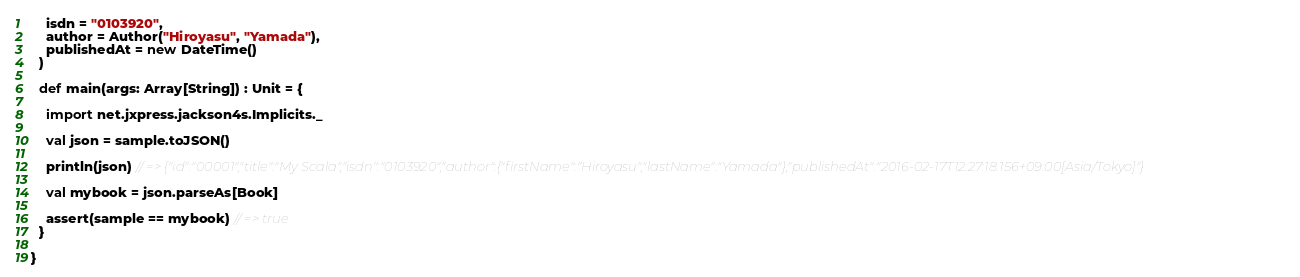Convert code to text. <code><loc_0><loc_0><loc_500><loc_500><_Scala_>    isdn = "0103920",
    author = Author("Hiroyasu", "Yamada"),
    publishedAt = new DateTime()
  )

  def main(args: Array[String]) : Unit = {

    import net.jxpress.jackson4s.Implicits._

    val json = sample.toJSON()

    println(json) // => {"id":"00001","title":"My Scala","isdn":"0103920","author":{"firstName":"Hiroyasu","lastName":"Yamada"},"publishedAt":"2016-02-17T12:27:18.156+09:00[Asia/Tokyo]"}

    val mybook = json.parseAs[Book]

    assert(sample == mybook) // => true
  }

}
</code> 